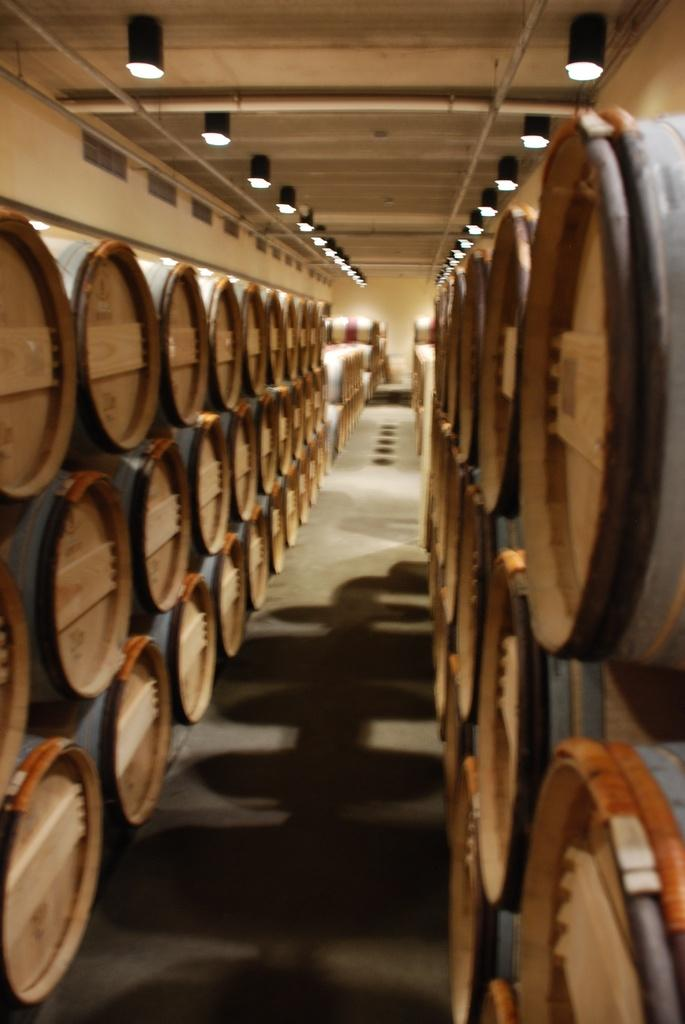What type of objects can be seen in the image? There are wooden boxes in the image. How are the wooden boxes arranged? The wooden boxes are arranged in various locations. What can be seen on the ceiling in the image? There are lights attached to the ceiling in the image. What time of day is it in the image, and what is the father doing? The provided facts do not mention the time of day or the presence of a father, so we cannot answer these questions based on the information given. 